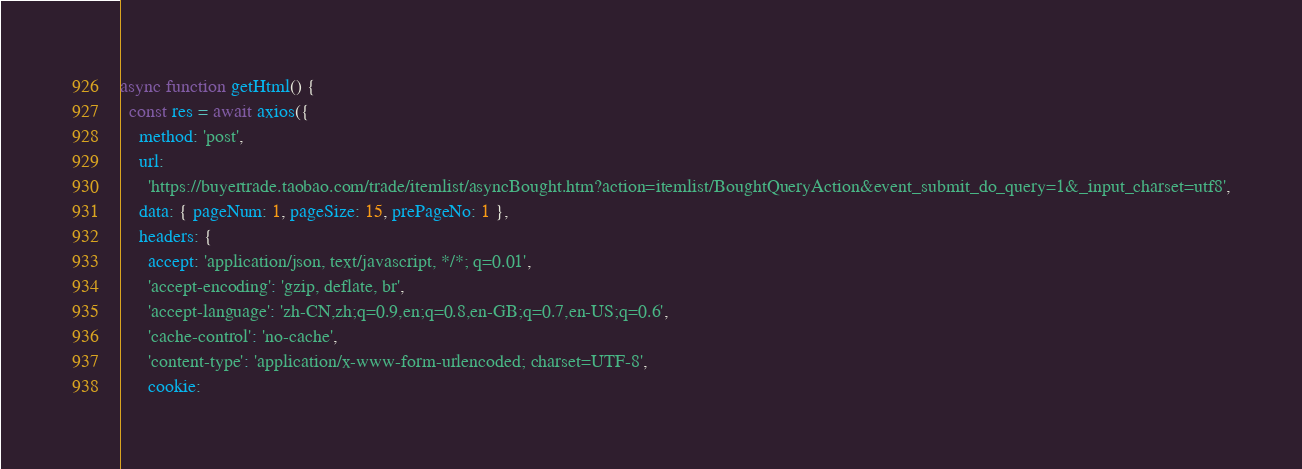<code> <loc_0><loc_0><loc_500><loc_500><_JavaScript_>async function getHtml() {
  const res = await axios({
    method: 'post',
    url:
      'https://buyertrade.taobao.com/trade/itemlist/asyncBought.htm?action=itemlist/BoughtQueryAction&event_submit_do_query=1&_input_charset=utf8',
    data: { pageNum: 1, pageSize: 15, prePageNo: 1 },
    headers: {
      accept: 'application/json, text/javascript, */*; q=0.01',
      'accept-encoding': 'gzip, deflate, br',
      'accept-language': 'zh-CN,zh;q=0.9,en;q=0.8,en-GB;q=0.7,en-US;q=0.6',
      'cache-control': 'no-cache',
      'content-type': 'application/x-www-form-urlencoded; charset=UTF-8',
      cookie:</code> 